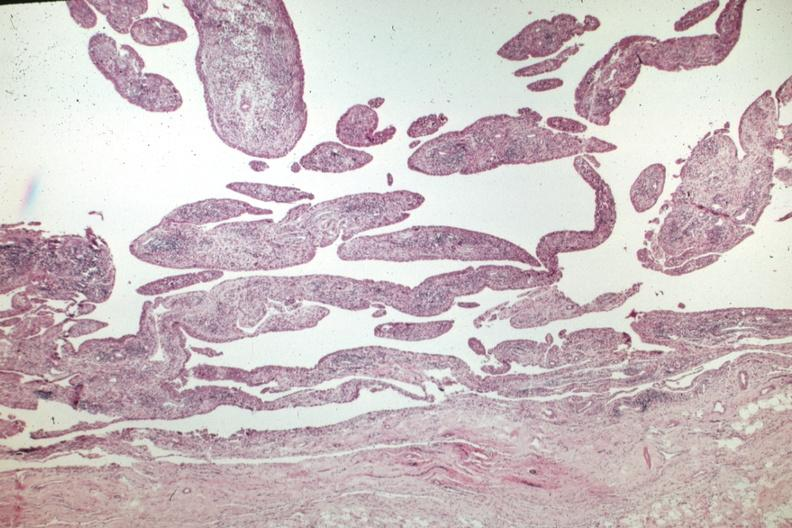does this image show villous lesion with chronic inflammatory cells?
Answer the question using a single word or phrase. Yes 